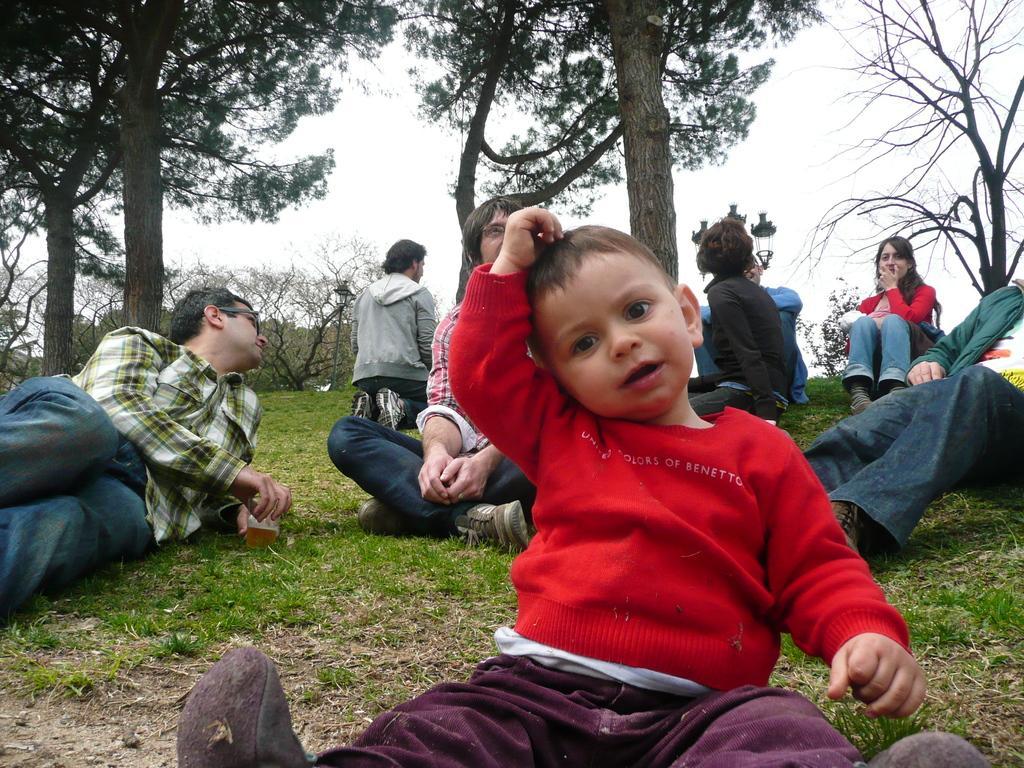Describe this image in one or two sentences. In front of the image there is a kid sitting on the grass surface, behind the kid there are a few people sitting on the grass surface, behind them there are trees and a lamp post. 